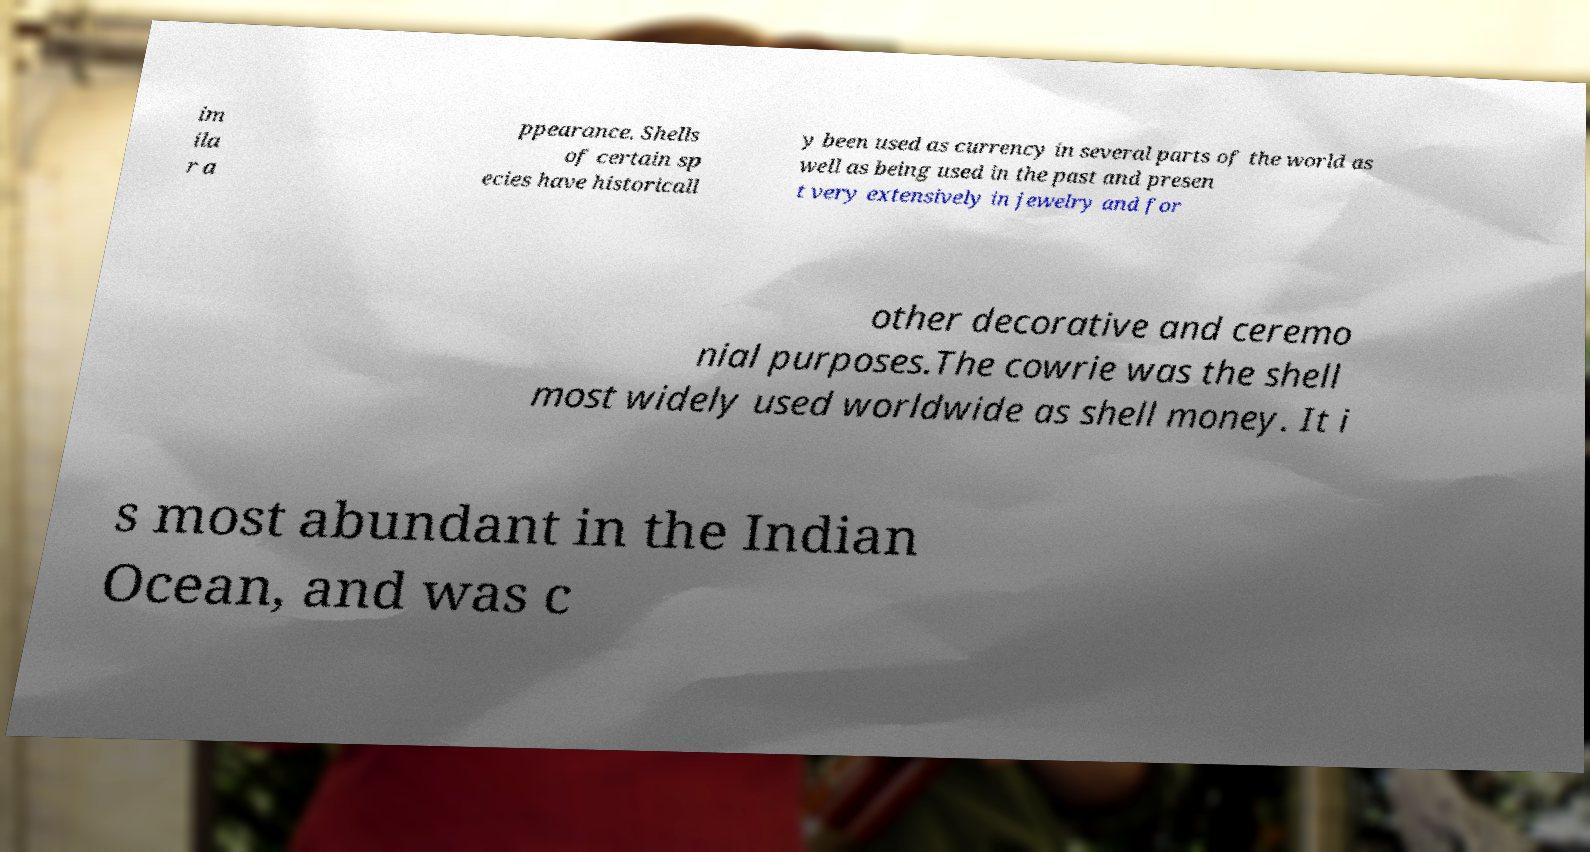Please read and relay the text visible in this image. What does it say? im ila r a ppearance. Shells of certain sp ecies have historicall y been used as currency in several parts of the world as well as being used in the past and presen t very extensively in jewelry and for other decorative and ceremo nial purposes.The cowrie was the shell most widely used worldwide as shell money. It i s most abundant in the Indian Ocean, and was c 